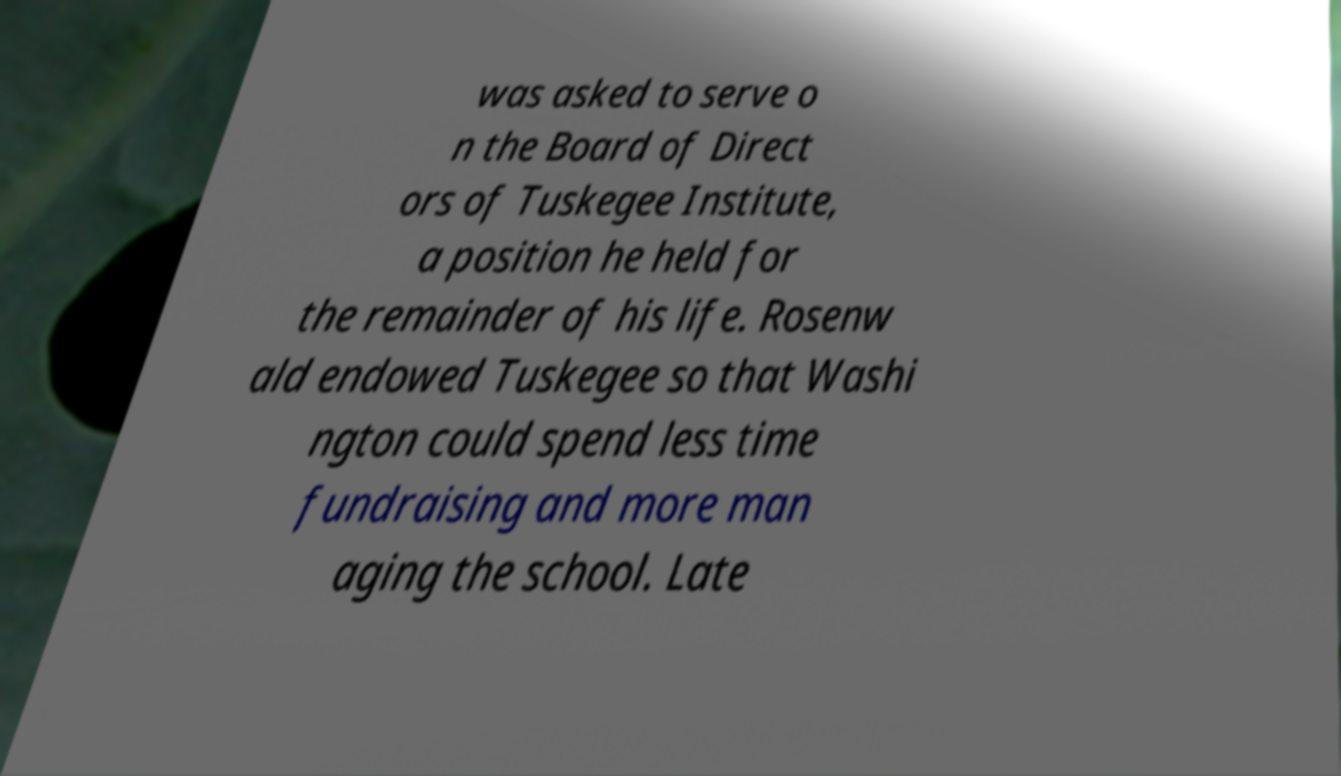For documentation purposes, I need the text within this image transcribed. Could you provide that? was asked to serve o n the Board of Direct ors of Tuskegee Institute, a position he held for the remainder of his life. Rosenw ald endowed Tuskegee so that Washi ngton could spend less time fundraising and more man aging the school. Late 